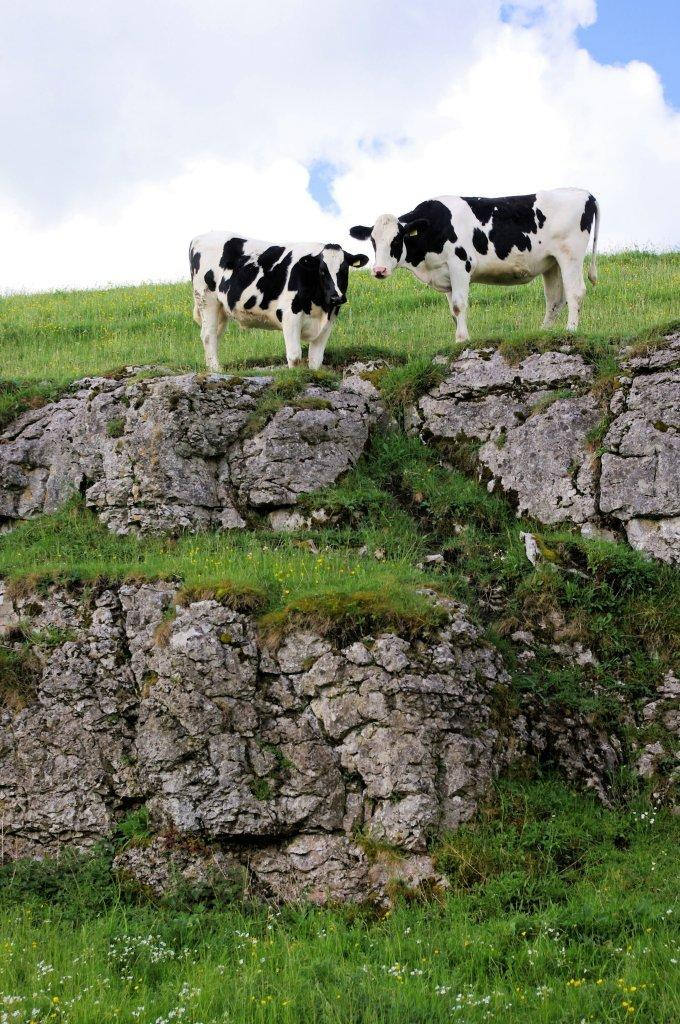How many cows are in the image? There are two cows in the image. What are the cows doing in the image? The cows are standing on the ground. What type of vegetation can be seen in the background of the image? There is grass visible in the background of the image. What else is visible in the background of the image? The sky is visible in the background of the image. What type of science experiment is being conducted with the cows in the image? There is no science experiment being conducted with the cows in the image; they are simply standing on the ground. What type of church can be seen in the background of the image? There is no church present in the image; it features two cows standing on the ground with grass and sky visible in the background. 